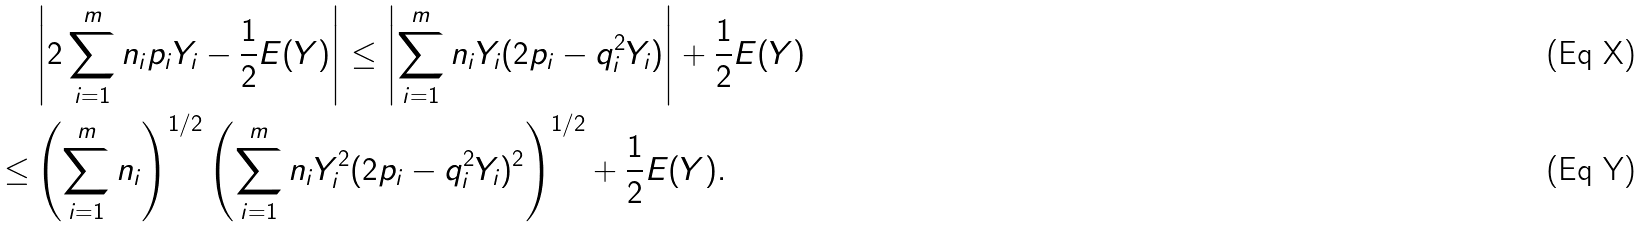<formula> <loc_0><loc_0><loc_500><loc_500>& \left | 2 \sum _ { i = 1 } ^ { m } n _ { i } p _ { i } Y _ { i } - \frac { 1 } { 2 } E ( Y ) \right | \leq \left | \sum _ { i = 1 } ^ { m } n _ { i } Y _ { i } ( 2 p _ { i } - q _ { i } ^ { 2 } Y _ { i } ) \right | + \frac { 1 } { 2 } E ( Y ) \\ \leq & \left ( \sum _ { i = 1 } ^ { m } n _ { i } \right ) ^ { 1 / 2 } \left ( \sum _ { i = 1 } ^ { m } n _ { i } Y _ { i } ^ { 2 } ( 2 p _ { i } - q _ { i } ^ { 2 } Y _ { i } ) ^ { 2 } \right ) ^ { 1 / 2 } + \frac { 1 } { 2 } E ( Y ) .</formula> 